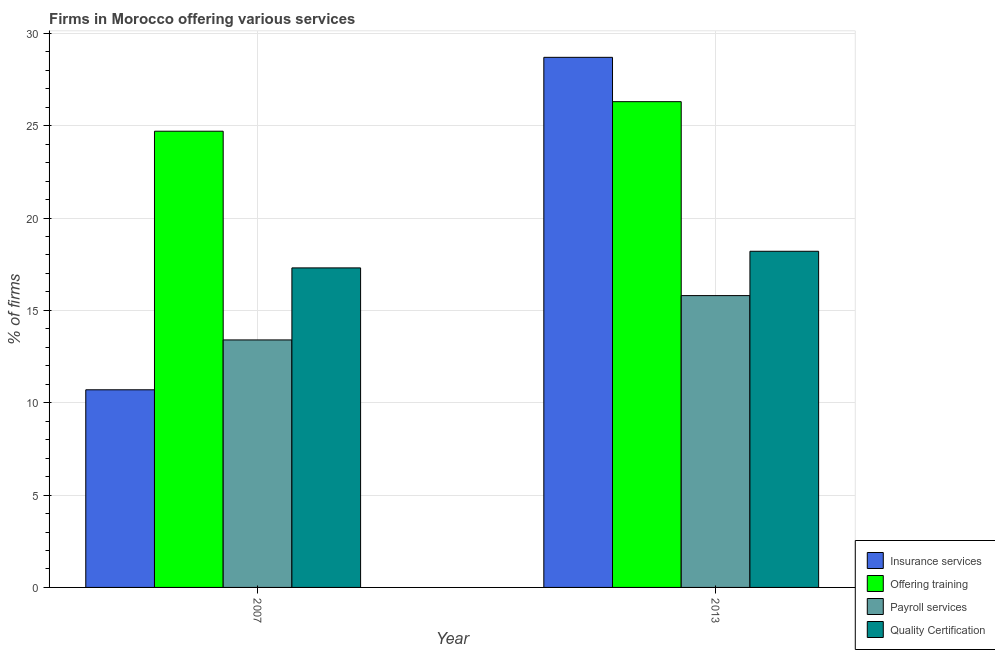How many groups of bars are there?
Keep it short and to the point. 2. Are the number of bars per tick equal to the number of legend labels?
Offer a very short reply. Yes. How many bars are there on the 1st tick from the left?
Offer a terse response. 4. How many bars are there on the 1st tick from the right?
Your response must be concise. 4. What is the percentage of firms offering insurance services in 2013?
Keep it short and to the point. 28.7. Across all years, what is the maximum percentage of firms offering training?
Provide a short and direct response. 26.3. Across all years, what is the minimum percentage of firms offering quality certification?
Your answer should be compact. 17.3. In which year was the percentage of firms offering insurance services maximum?
Your answer should be compact. 2013. What is the total percentage of firms offering insurance services in the graph?
Offer a terse response. 39.4. What is the difference between the percentage of firms offering training in 2007 and that in 2013?
Provide a short and direct response. -1.6. What is the ratio of the percentage of firms offering payroll services in 2007 to that in 2013?
Provide a succinct answer. 0.85. Is the percentage of firms offering insurance services in 2007 less than that in 2013?
Offer a very short reply. Yes. What does the 3rd bar from the left in 2007 represents?
Offer a very short reply. Payroll services. What does the 3rd bar from the right in 2007 represents?
Provide a short and direct response. Offering training. Is it the case that in every year, the sum of the percentage of firms offering insurance services and percentage of firms offering training is greater than the percentage of firms offering payroll services?
Give a very brief answer. Yes. How many bars are there?
Keep it short and to the point. 8. Are all the bars in the graph horizontal?
Offer a very short reply. No. How many years are there in the graph?
Offer a very short reply. 2. What is the difference between two consecutive major ticks on the Y-axis?
Offer a terse response. 5. Are the values on the major ticks of Y-axis written in scientific E-notation?
Your answer should be very brief. No. Does the graph contain any zero values?
Provide a succinct answer. No. Does the graph contain grids?
Make the answer very short. Yes. How are the legend labels stacked?
Your answer should be very brief. Vertical. What is the title of the graph?
Keep it short and to the point. Firms in Morocco offering various services . Does "Taxes on goods and services" appear as one of the legend labels in the graph?
Provide a succinct answer. No. What is the label or title of the Y-axis?
Ensure brevity in your answer.  % of firms. What is the % of firms of Insurance services in 2007?
Make the answer very short. 10.7. What is the % of firms of Offering training in 2007?
Offer a very short reply. 24.7. What is the % of firms in Insurance services in 2013?
Your answer should be very brief. 28.7. What is the % of firms of Offering training in 2013?
Make the answer very short. 26.3. Across all years, what is the maximum % of firms of Insurance services?
Give a very brief answer. 28.7. Across all years, what is the maximum % of firms in Offering training?
Keep it short and to the point. 26.3. Across all years, what is the maximum % of firms of Payroll services?
Make the answer very short. 15.8. Across all years, what is the minimum % of firms in Offering training?
Provide a short and direct response. 24.7. Across all years, what is the minimum % of firms in Payroll services?
Your answer should be very brief. 13.4. Across all years, what is the minimum % of firms of Quality Certification?
Offer a very short reply. 17.3. What is the total % of firms of Insurance services in the graph?
Your answer should be very brief. 39.4. What is the total % of firms of Payroll services in the graph?
Ensure brevity in your answer.  29.2. What is the total % of firms in Quality Certification in the graph?
Provide a short and direct response. 35.5. What is the difference between the % of firms in Quality Certification in 2007 and that in 2013?
Your response must be concise. -0.9. What is the difference between the % of firms of Insurance services in 2007 and the % of firms of Offering training in 2013?
Make the answer very short. -15.6. What is the difference between the % of firms of Insurance services in 2007 and the % of firms of Payroll services in 2013?
Keep it short and to the point. -5.1. What is the difference between the % of firms of Offering training in 2007 and the % of firms of Payroll services in 2013?
Provide a succinct answer. 8.9. What is the difference between the % of firms in Offering training in 2007 and the % of firms in Quality Certification in 2013?
Offer a terse response. 6.5. What is the average % of firms in Insurance services per year?
Make the answer very short. 19.7. What is the average % of firms of Payroll services per year?
Offer a terse response. 14.6. What is the average % of firms in Quality Certification per year?
Give a very brief answer. 17.75. In the year 2007, what is the difference between the % of firms in Insurance services and % of firms in Offering training?
Offer a very short reply. -14. In the year 2007, what is the difference between the % of firms in Offering training and % of firms in Quality Certification?
Keep it short and to the point. 7.4. In the year 2013, what is the difference between the % of firms of Insurance services and % of firms of Offering training?
Ensure brevity in your answer.  2.4. In the year 2013, what is the difference between the % of firms in Insurance services and % of firms in Quality Certification?
Keep it short and to the point. 10.5. In the year 2013, what is the difference between the % of firms in Offering training and % of firms in Quality Certification?
Your answer should be very brief. 8.1. In the year 2013, what is the difference between the % of firms of Payroll services and % of firms of Quality Certification?
Offer a very short reply. -2.4. What is the ratio of the % of firms of Insurance services in 2007 to that in 2013?
Provide a succinct answer. 0.37. What is the ratio of the % of firms of Offering training in 2007 to that in 2013?
Provide a short and direct response. 0.94. What is the ratio of the % of firms of Payroll services in 2007 to that in 2013?
Your response must be concise. 0.85. What is the ratio of the % of firms of Quality Certification in 2007 to that in 2013?
Offer a terse response. 0.95. What is the difference between the highest and the second highest % of firms in Offering training?
Keep it short and to the point. 1.6. What is the difference between the highest and the second highest % of firms of Payroll services?
Ensure brevity in your answer.  2.4. What is the difference between the highest and the second highest % of firms of Quality Certification?
Your response must be concise. 0.9. 